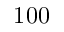Convert formula to latex. <formula><loc_0><loc_0><loc_500><loc_500>1 0 0</formula> 